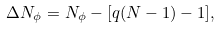Convert formula to latex. <formula><loc_0><loc_0><loc_500><loc_500>\Delta N _ { \phi } = N _ { \phi } - [ q ( N - 1 ) - 1 ] ,</formula> 